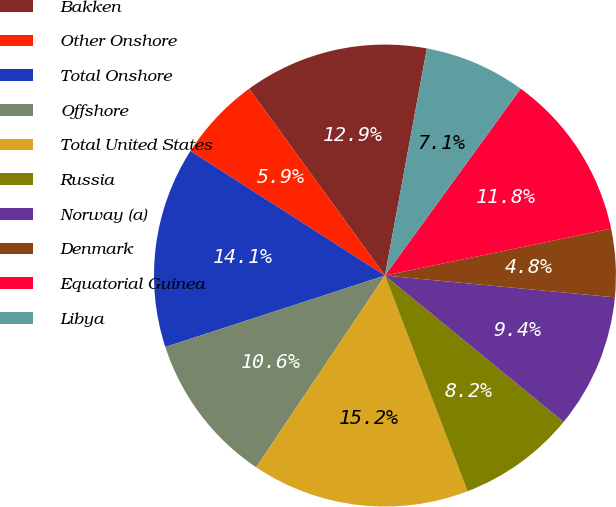<chart> <loc_0><loc_0><loc_500><loc_500><pie_chart><fcel>Bakken<fcel>Other Onshore<fcel>Total Onshore<fcel>Offshore<fcel>Total United States<fcel>Russia<fcel>Norway (a)<fcel>Denmark<fcel>Equatorial Guinea<fcel>Libya<nl><fcel>12.91%<fcel>5.93%<fcel>14.07%<fcel>10.58%<fcel>15.24%<fcel>8.25%<fcel>9.42%<fcel>4.76%<fcel>11.75%<fcel>7.09%<nl></chart> 